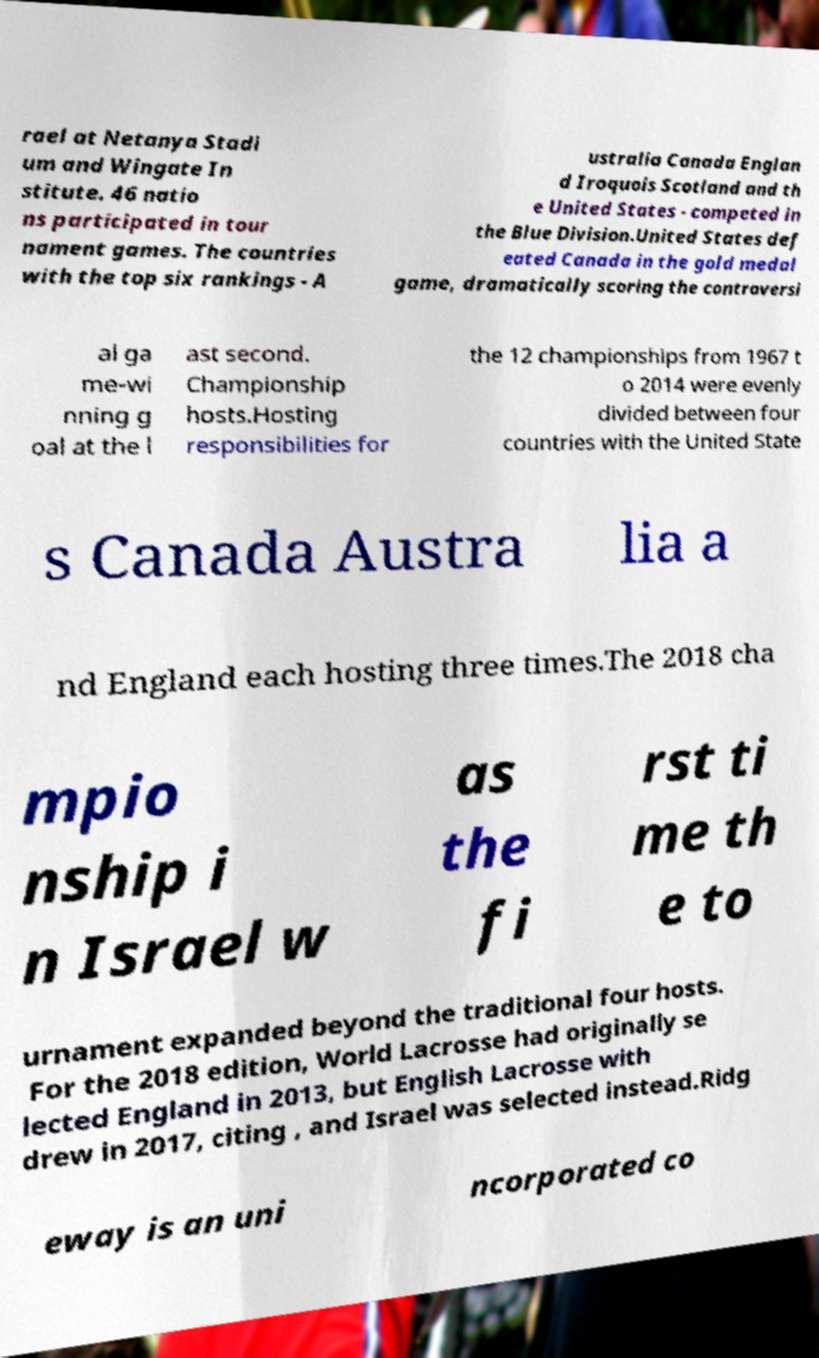There's text embedded in this image that I need extracted. Can you transcribe it verbatim? rael at Netanya Stadi um and Wingate In stitute. 46 natio ns participated in tour nament games. The countries with the top six rankings - A ustralia Canada Englan d Iroquois Scotland and th e United States - competed in the Blue Division.United States def eated Canada in the gold medal game, dramatically scoring the controversi al ga me-wi nning g oal at the l ast second. Championship hosts.Hosting responsibilities for the 12 championships from 1967 t o 2014 were evenly divided between four countries with the United State s Canada Austra lia a nd England each hosting three times.The 2018 cha mpio nship i n Israel w as the fi rst ti me th e to urnament expanded beyond the traditional four hosts. For the 2018 edition, World Lacrosse had originally se lected England in 2013, but English Lacrosse with drew in 2017, citing , and Israel was selected instead.Ridg eway is an uni ncorporated co 